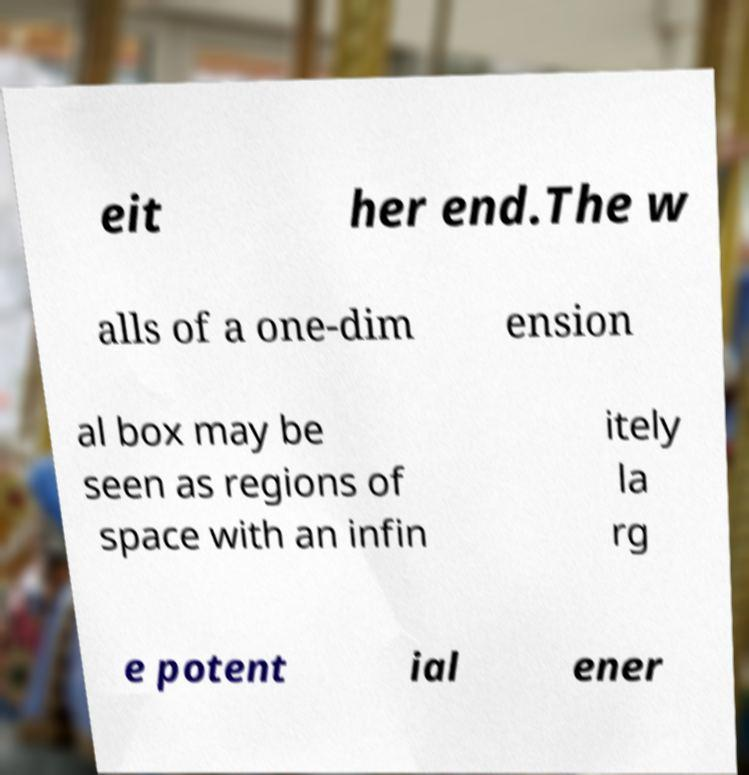Can you read and provide the text displayed in the image?This photo seems to have some interesting text. Can you extract and type it out for me? eit her end.The w alls of a one-dim ension al box may be seen as regions of space with an infin itely la rg e potent ial ener 